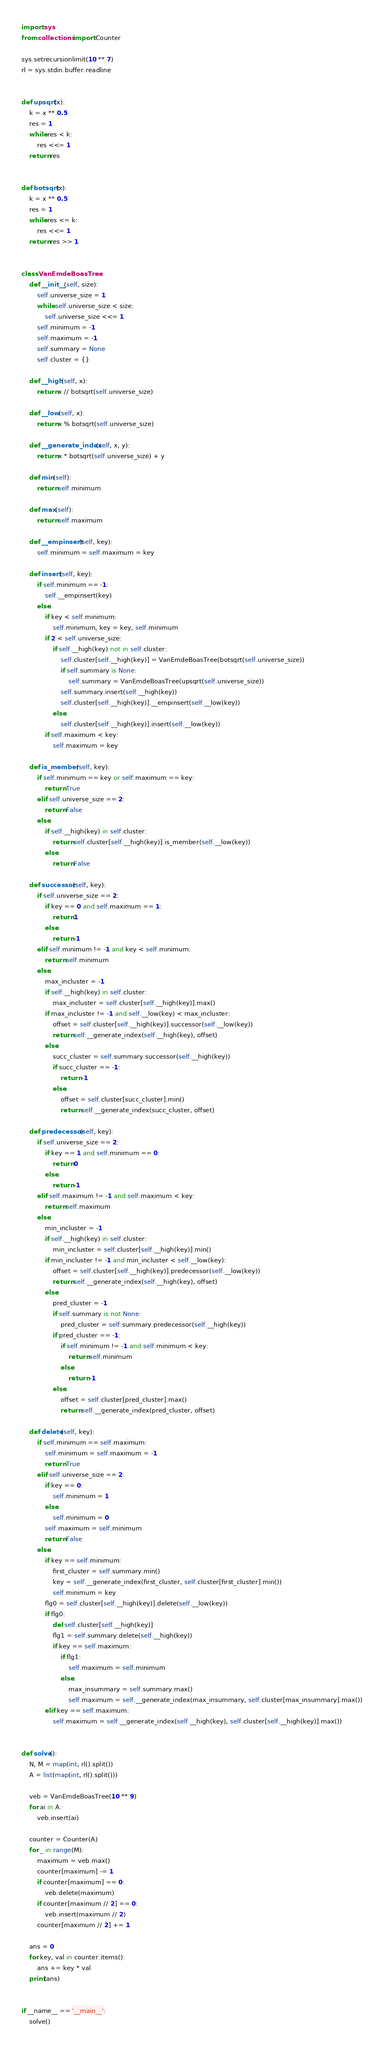<code> <loc_0><loc_0><loc_500><loc_500><_Cython_>import sys
from collections import Counter

sys.setrecursionlimit(10 ** 7)
rl = sys.stdin.buffer.readline


def upsqrt(x):
    k = x ** 0.5
    res = 1
    while res < k:
        res <<= 1
    return res


def botsqrt(x):
    k = x ** 0.5
    res = 1
    while res <= k:
        res <<= 1
    return res >> 1


class VanEmdeBoasTree:
    def __init__(self, size):
        self.universe_size = 1
        while self.universe_size < size:
            self.universe_size <<= 1
        self.minimum = -1
        self.maximum = -1
        self.summary = None
        self.cluster = {}
    
    def __high(self, x):
        return x // botsqrt(self.universe_size)
    
    def __low(self, x):
        return x % botsqrt(self.universe_size)
    
    def __generate_index(self, x, y):
        return x * botsqrt(self.universe_size) + y
    
    def min(self):
        return self.minimum
    
    def max(self):
        return self.maximum
    
    def __empinsert(self, key):
        self.minimum = self.maximum = key
    
    def insert(self, key):
        if self.minimum == -1:
            self.__empinsert(key)
        else:
            if key < self.minimum:
                self.minimum, key = key, self.minimum
            if 2 < self.universe_size:
                if self.__high(key) not in self.cluster:
                    self.cluster[self.__high(key)] = VanEmdeBoasTree(botsqrt(self.universe_size))
                    if self.summary is None:
                        self.summary = VanEmdeBoasTree(upsqrt(self.universe_size))
                    self.summary.insert(self.__high(key))
                    self.cluster[self.__high(key)].__empinsert(self.__low(key))
                else:
                    self.cluster[self.__high(key)].insert(self.__low(key))
            if self.maximum < key:
                self.maximum = key
    
    def is_member(self, key):
        if self.minimum == key or self.maximum == key:
            return True
        elif self.universe_size == 2:
            return False
        else:
            if self.__high(key) in self.cluster:
                return self.cluster[self.__high(key)].is_member(self.__low(key))
            else:
                return False
    
    def successor(self, key):
        if self.universe_size == 2:
            if key == 0 and self.maximum == 1:
                return 1
            else:
                return -1
        elif self.minimum != -1 and key < self.minimum:
            return self.minimum
        else:
            max_incluster = -1
            if self.__high(key) in self.cluster:
                max_incluster = self.cluster[self.__high(key)].max()
            if max_incluster != -1 and self.__low(key) < max_incluster:
                offset = self.cluster[self.__high(key)].successor(self.__low(key))
                return self.__generate_index(self.__high(key), offset)
            else:
                succ_cluster = self.summary.successor(self.__high(key))
                if succ_cluster == -1:
                    return -1
                else:
                    offset = self.cluster[succ_cluster].min()
                    return self.__generate_index(succ_cluster, offset)
    
    def predecessor(self, key):
        if self.universe_size == 2:
            if key == 1 and self.minimum == 0:
                return 0
            else:
                return -1
        elif self.maximum != -1 and self.maximum < key:
            return self.maximum
        else:
            min_incluster = -1
            if self.__high(key) in self.cluster:
                min_incluster = self.cluster[self.__high(key)].min()
            if min_incluster != -1 and min_incluster < self.__low(key):
                offset = self.cluster[self.__high(key)].predecessor(self.__low(key))
                return self.__generate_index(self.__high(key), offset)
            else:
                pred_cluster = -1
                if self.summary is not None:
                    pred_cluster = self.summary.predecessor(self.__high(key))
                if pred_cluster == -1:
                    if self.minimum != -1 and self.minimum < key:
                        return self.minimum
                    else:
                        return -1
                else:
                    offset = self.cluster[pred_cluster].max()
                    return self.__generate_index(pred_cluster, offset)
    
    def delete(self, key):
        if self.minimum == self.maximum:
            self.minimum = self.maximum = -1
            return True
        elif self.universe_size == 2:
            if key == 0:
                self.minimum = 1
            else:
                self.minimum = 0
            self.maximum = self.minimum
            return False
        else:
            if key == self.minimum:
                first_cluster = self.summary.min()
                key = self.__generate_index(first_cluster, self.cluster[first_cluster].min())
                self.minimum = key
            flg0 = self.cluster[self.__high(key)].delete(self.__low(key))
            if flg0:
                del self.cluster[self.__high(key)]
                flg1 = self.summary.delete(self.__high(key))
                if key == self.maximum:
                    if flg1:
                        self.maximum = self.minimum
                    else:
                        max_insummary = self.summary.max()
                        self.maximum = self.__generate_index(max_insummary, self.cluster[max_insummary].max())
            elif key == self.maximum:
                self.maximum = self.__generate_index(self.__high(key), self.cluster[self.__high(key)].max())


def solve():
    N, M = map(int, rl().split())
    A = list(map(int, rl().split()))
    
    veb = VanEmdeBoasTree(10 ** 9)
    for ai in A:
        veb.insert(ai)
    
    counter = Counter(A)
    for _ in range(M):
        maximum = veb.max()
        counter[maximum] -= 1
        if counter[maximum] == 0:
            veb.delete(maximum)
        if counter[maximum // 2] == 0:
            veb.insert(maximum // 2)
        counter[maximum // 2] += 1
    
    ans = 0
    for key, val in counter.items():
        ans += key * val
    print(ans)


if __name__ == '__main__':
    solve()
</code> 